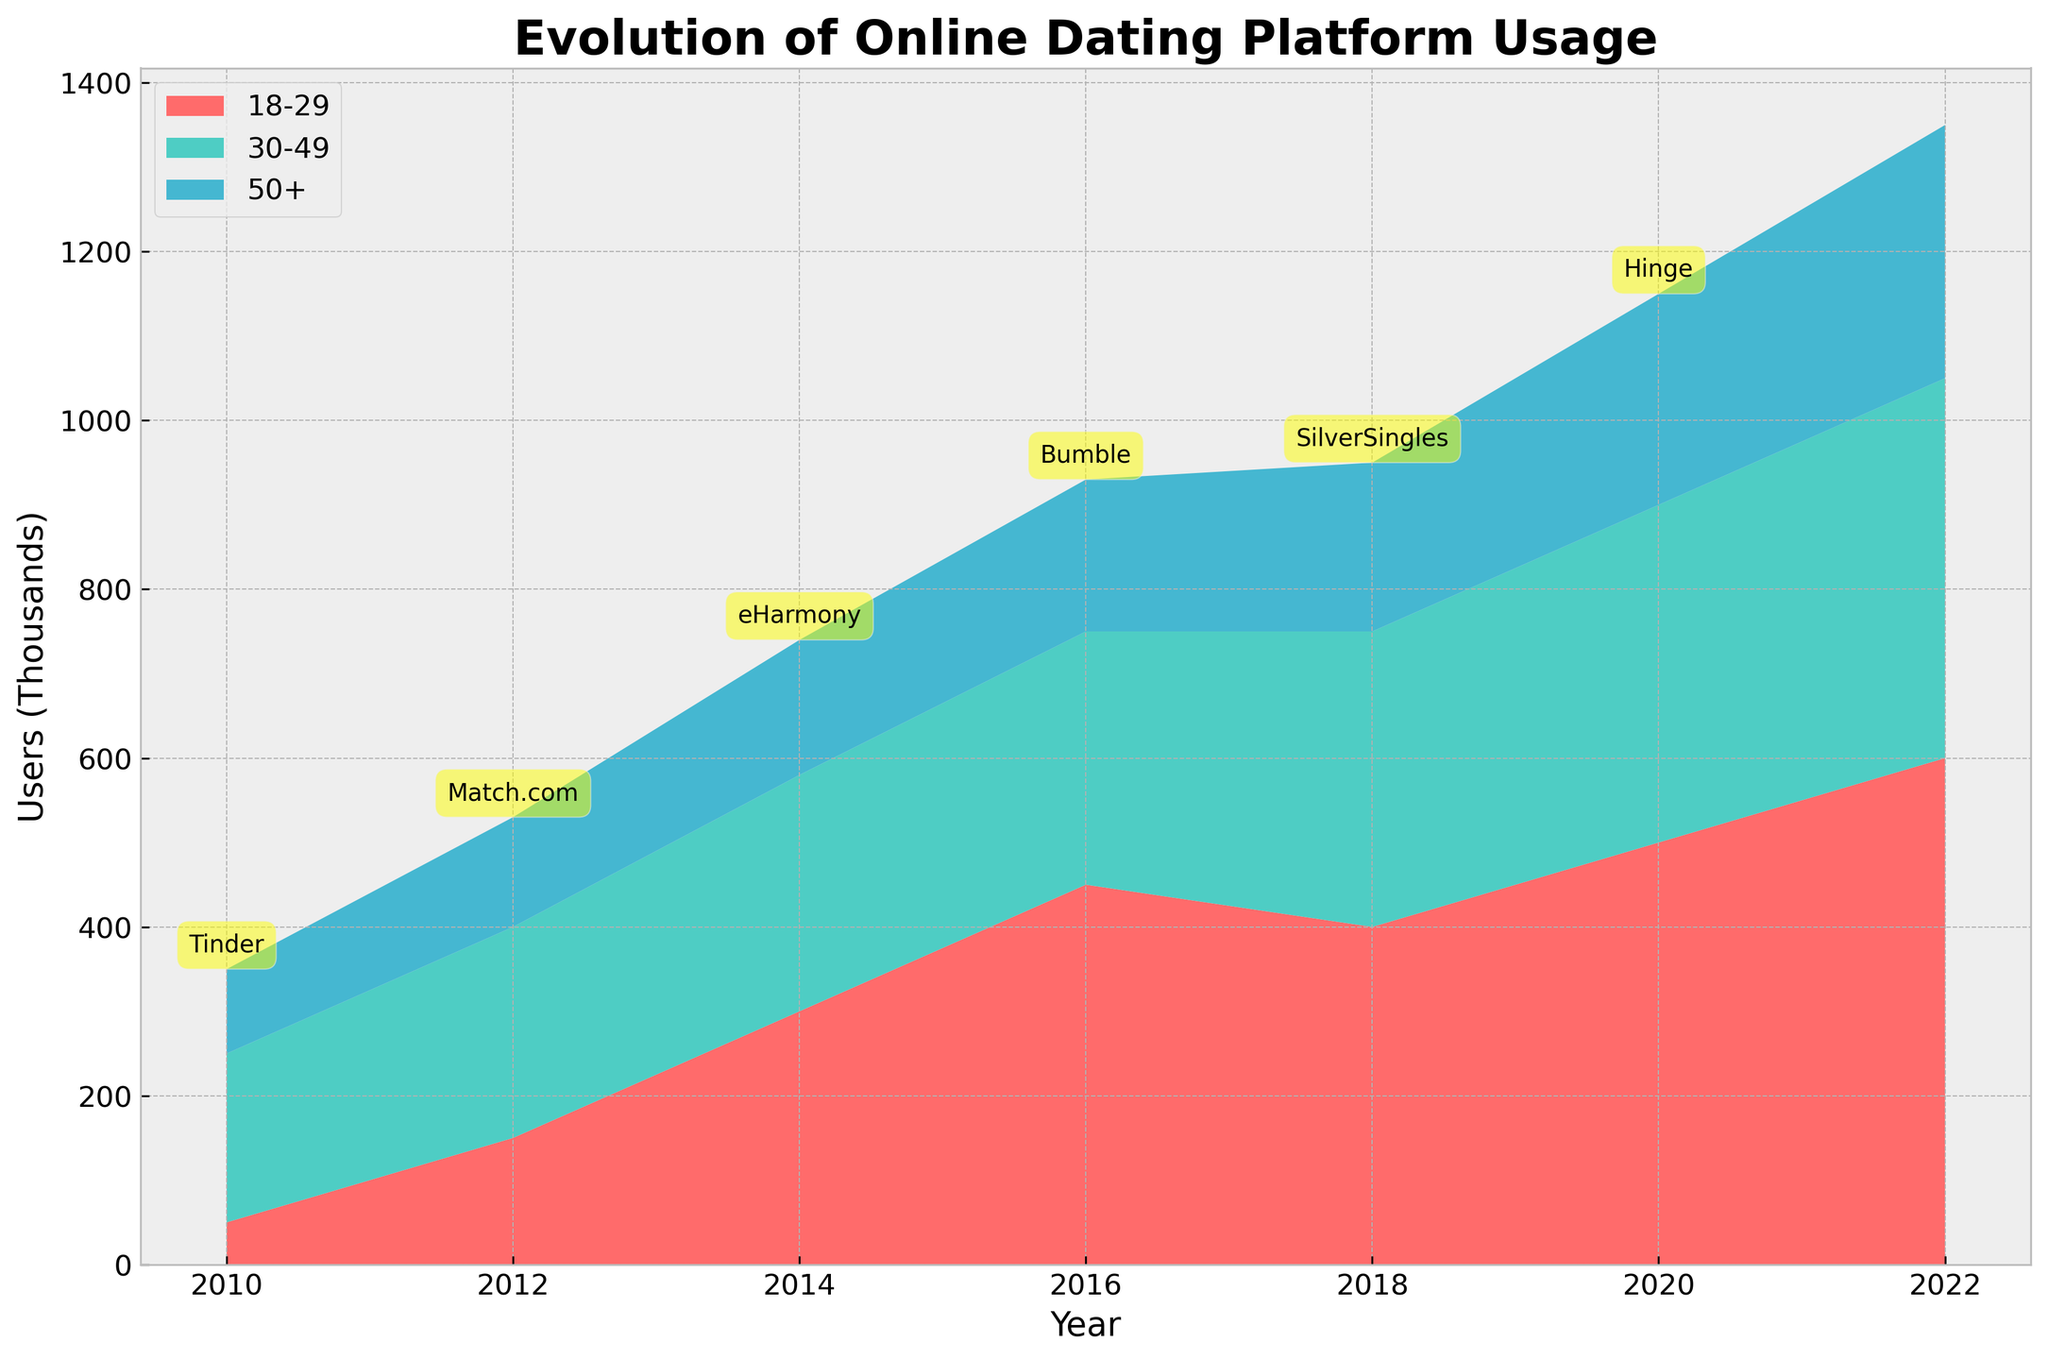what is the title of the plot? The title of the plot is usually situated at the top of the figure, clearly stating what the plot is about. Look at the upper portion of the figure where the larger and bolder text typically appears.
Answer: Evolution of Online Dating Platform Usage How many age groups are represented in the plot? Different age groups are distinguished by varying colors, and each color group is labeled in the legend of the figure. By counting these labels, we can determine the number of age groups.
Answer: 3 Which age group had the highest user count in 2010? By examining the year 2010 on the x-axis and comparing the vertical extent (height) of each colored section that represents different age groups, we can identify which group's segment extends the highest.
Answer: 30-49 In which year did the '18-29' age group's user count peak? Track the height of the segment corresponding to the '18-29' age group across the years on the x-axis and identify the year with the highest point.
Answer: 2022 Comparing 2018 and 2020, how did the user count for the '50+' age group change? Locate the segments for the '50+' age group in both 2018 and 2020. By visually inspecting the height or thickness of these segments, we can compare them directly to ascertain whether the user count increased or decreased.
Answer: Increased Which platform was used by the '30-49' age group in 2016? The plot includes annotations for platforms specific to each year. By locating the year 2016 and checking the annotation overlapping the segment for the '30-49' age group, we can identify the platform used.
Answer: Match.com What is the trend in user count for the '50+' age group from 2010 to 2022? Follow the segment representing the '50+' age group along the x-axis from 2010 to 2022 to observe changes in height. An increasing trend is indicated by a consistently rising segment, while a decreasing or fluctuating trend will show corresponding declines or irregular patterns.
Answer: Increasing What is the difference in user count for the '18-29' age group between 2014 and 2016? Identify the vertical extents (height) of the '18-29' segments for the years 2014 and 2016 from the plot. Subtract the 2014 user count from the 2016 user count to get the difference.
Answer: 150,000 users Which age group shows more significant diversity in platform usage over the years? Look at the variety of colors (platforms) annotated within each age group's segments across different years. The age group with more platform types annotated suggests greater diversity in usage.
Answer: 18-29 Are there any years where all three age groups used different platforms? Examine each annotated year on the plot, noting the platforms associated with each age group's segments. Identify if any year shows distinct platforms being used by all three age groups simultaneously.
Answer: 2022 